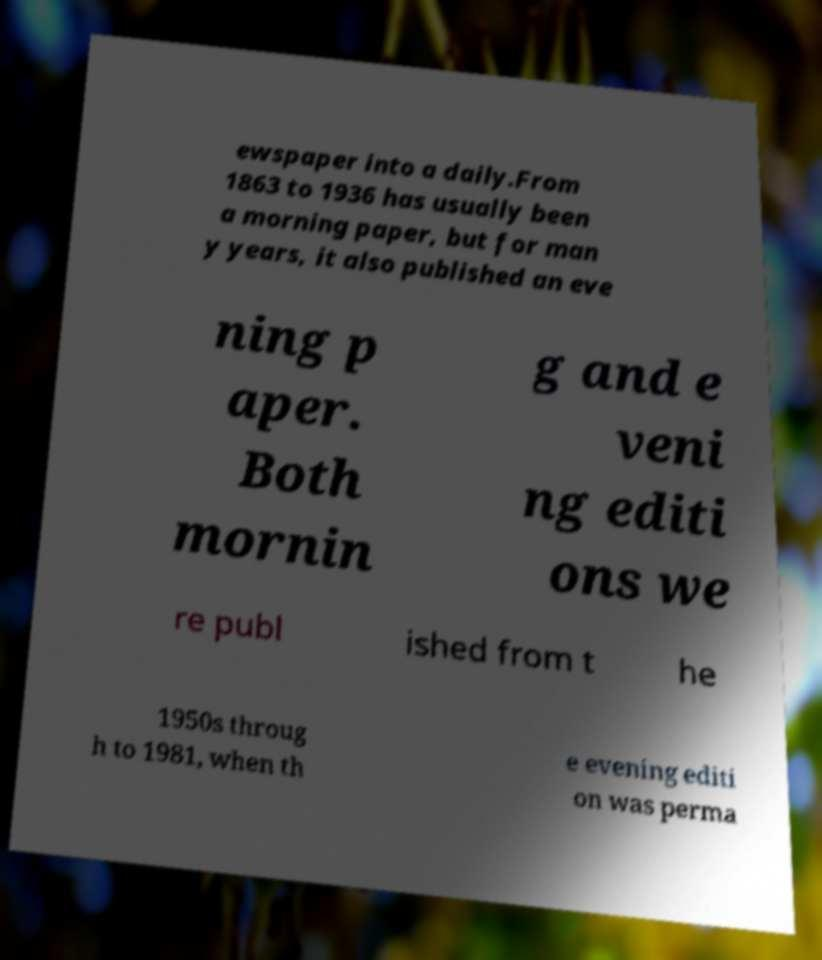There's text embedded in this image that I need extracted. Can you transcribe it verbatim? ewspaper into a daily.From 1863 to 1936 has usually been a morning paper, but for man y years, it also published an eve ning p aper. Both mornin g and e veni ng editi ons we re publ ished from t he 1950s throug h to 1981, when th e evening editi on was perma 